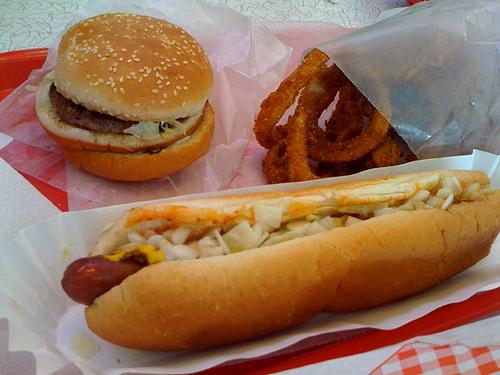Where could you get this food? Please explain your reasoning. burger joint. The food is a burger joint snack. 